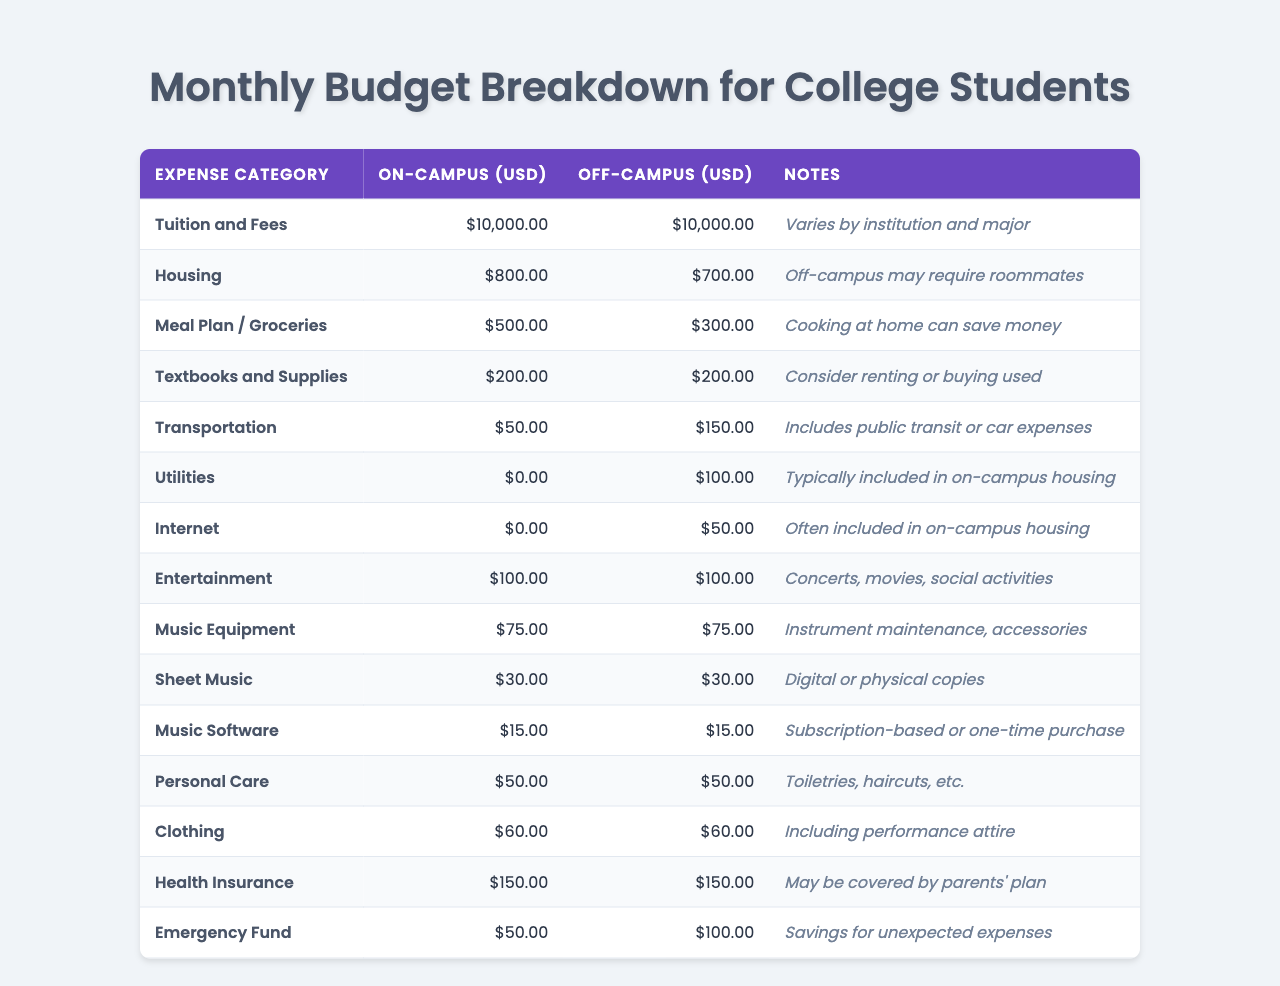What's the monthly cost for housing on-campus? The table shows that the monthly cost for housing on-campus is listed as $800.
Answer: $800 What's the total monthly budget for a student living off-campus? To find the total, we sum all off-campus expenses: $10,000 (tuition) + $700 (housing) + $300 (groceries) + $200 (textbooks) + $150 (transportation) + $100 (utilities) + $50 (internet) + $100 (entertainment) + $75 (music equipment) + $30 (sheet music) + $15 (music software) + $50 (personal care) + $60 (clothing) + $150 (health insurance) + $100 (emergency fund) = $12,720.
Answer: $12,720 Is the on-campus transportation cost lower than off-campus? The transportation cost on-campus is $50 while off-campus it's $150, making it lower on-campus.
Answer: Yes How much more does a student pay for utilities when living off-campus compared to on-campus? The table shows that utilities cost $100 off-campus and $0 on-campus. The difference is $100 - $0 = $100.
Answer: $100 What's the average monthly expense for a student living on-campus? To find the average, we first need to calculate the total expenses for on-campus: $10,000 (tuition) + $800 (housing) + $500 (groceries) + $200 (textbooks) + $50 (transportation) + $0 (utilities) + $0 (internet) + $100 (entertainment) + $75 (music equipment) + $30 (sheet music) + $15 (music software) + $50 (personal care) + $60 (clothing) + $150 (health insurance) + $50 (emergency fund) = $12,020. Since there are 14 categories, the average is $12,020 / 14 = $858.57.
Answer: $858.57 What is the total cost for textbooks and supplies for both on-campus and off-campus students? The textbooks and supplies cost $200 for both on-campus and off-campus, so the total cost is $200 + $200 = $400.
Answer: $400 Is it true that students living off-campus spend more on groceries than those living on-campus? The table indicates that on-campus students spend $500 on groceries while off-campus students spend $300, which means on-campus students spend more.
Answer: No What is the difference in monthly emergency fund expenses between on-campus and off-campus students? The emergency fund is $50 for on-campus students and $100 for off-campus students, so the difference is $100 - $50 = $50.
Answer: $50 If a student wanted to reduce their transportation costs to that of an on-campus student, how much would they save living off-campus? The off-campus transportation cost is $150 and the on-campus cost is $50, so the savings would be $150 - $50 = $100.
Answer: $100 What is the total amount spent on music equipment for both living situations? The table shows music equipment costs $75 for both on-campus and off-campus students. The total amount spent is $75 + $75 = $150.
Answer: $150 How much does off-campus housing cost compared to on-campus housing? Off-campus housing costs $700, while on-campus housing costs $800. The difference is $800 - $700 = $100, meaning off-campus housing is cheaper.
Answer: $100 